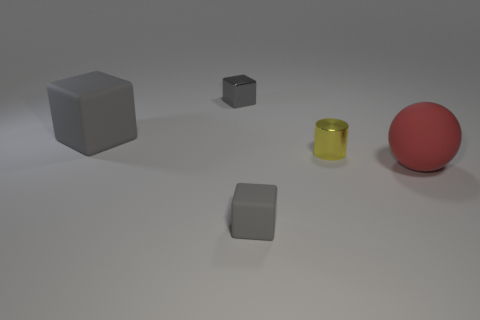Subtract all metal blocks. How many blocks are left? 2 Add 2 blocks. How many objects exist? 7 Subtract all cylinders. How many objects are left? 4 Subtract 1 balls. How many balls are left? 0 Add 2 small cubes. How many small cubes are left? 4 Add 3 tiny yellow shiny cylinders. How many tiny yellow shiny cylinders exist? 4 Subtract 1 gray cubes. How many objects are left? 4 Subtract all blue blocks. Subtract all yellow cylinders. How many blocks are left? 3 Subtract all brown cubes. How many yellow balls are left? 0 Subtract all tiny gray metallic cubes. Subtract all large gray cubes. How many objects are left? 3 